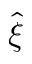<formula> <loc_0><loc_0><loc_500><loc_500>\hat { \xi }</formula> 